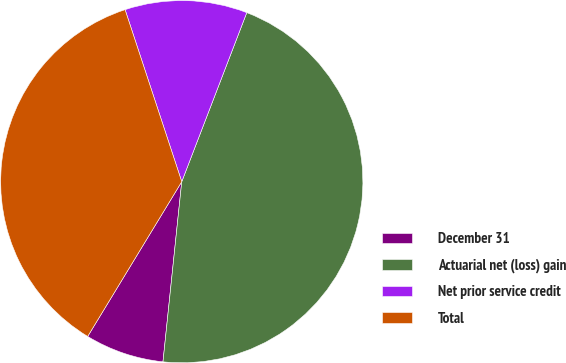Convert chart. <chart><loc_0><loc_0><loc_500><loc_500><pie_chart><fcel>December 31<fcel>Actuarial net (loss) gain<fcel>Net prior service credit<fcel>Total<nl><fcel>7.04%<fcel>45.81%<fcel>10.91%<fcel>36.24%<nl></chart> 